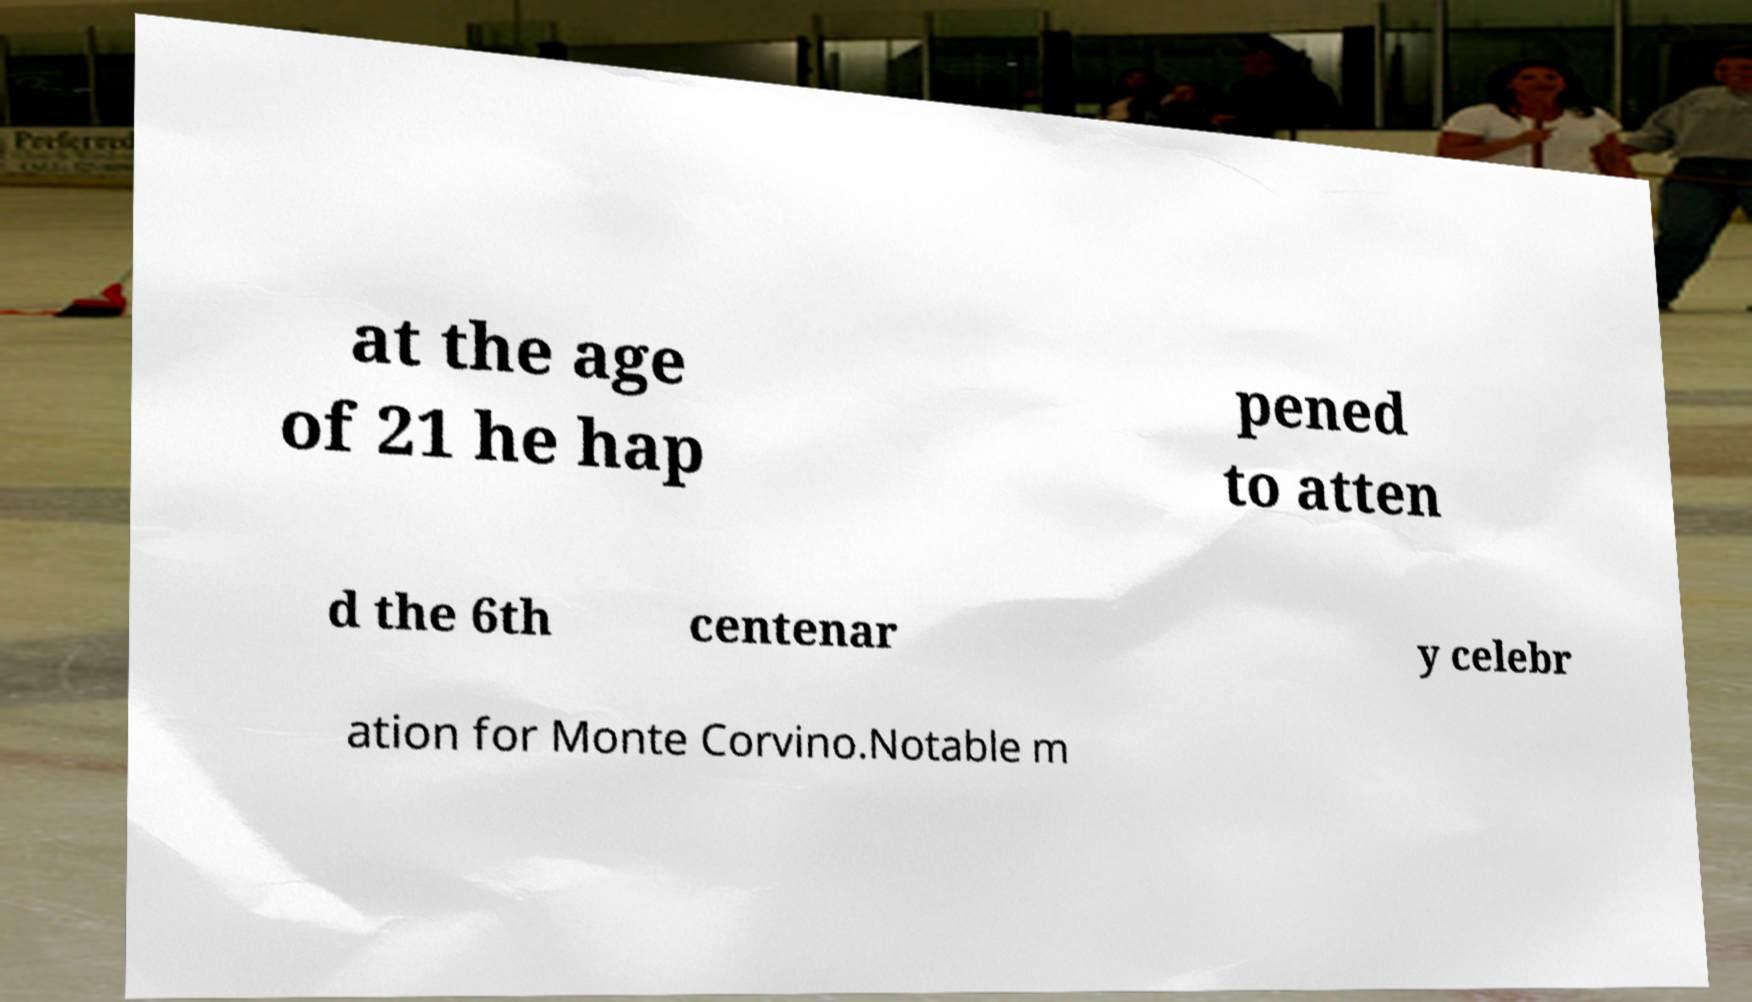I need the written content from this picture converted into text. Can you do that? at the age of 21 he hap pened to atten d the 6th centenar y celebr ation for Monte Corvino.Notable m 